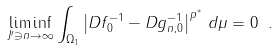<formula> <loc_0><loc_0><loc_500><loc_500>\liminf _ { J ^ { \prime } \ni n \to \infty } \int _ { \Omega _ { 1 } } \left | D f _ { 0 } ^ { - 1 } - D g _ { n , 0 } ^ { - 1 } \right | ^ { p ^ { * } } \, d \mu = 0 \ .</formula> 